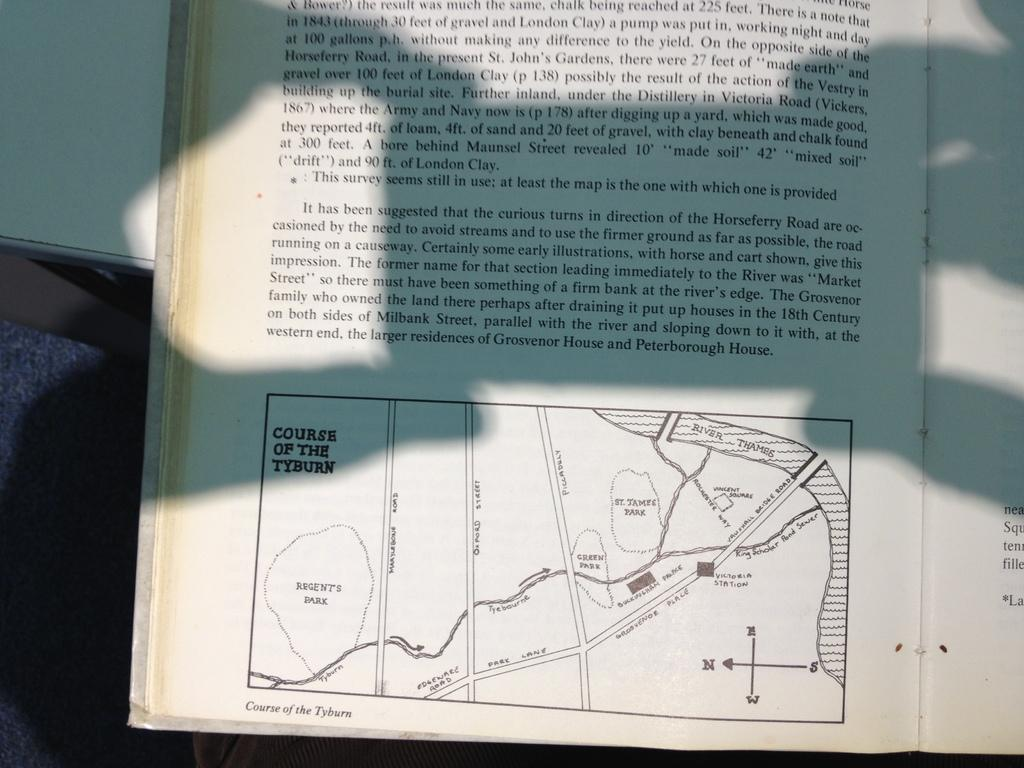Provide a one-sentence caption for the provided image. Book that includes a map about the courses of the Tyburn. 